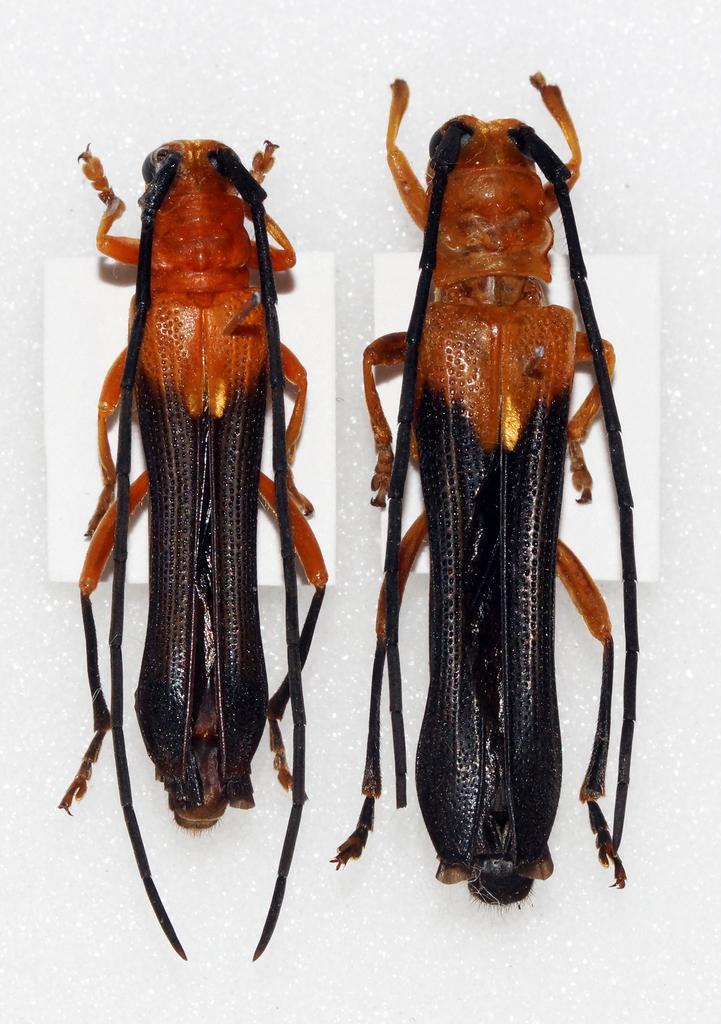Please provide a concise description of this image. In this picture we can see couple of insects. 